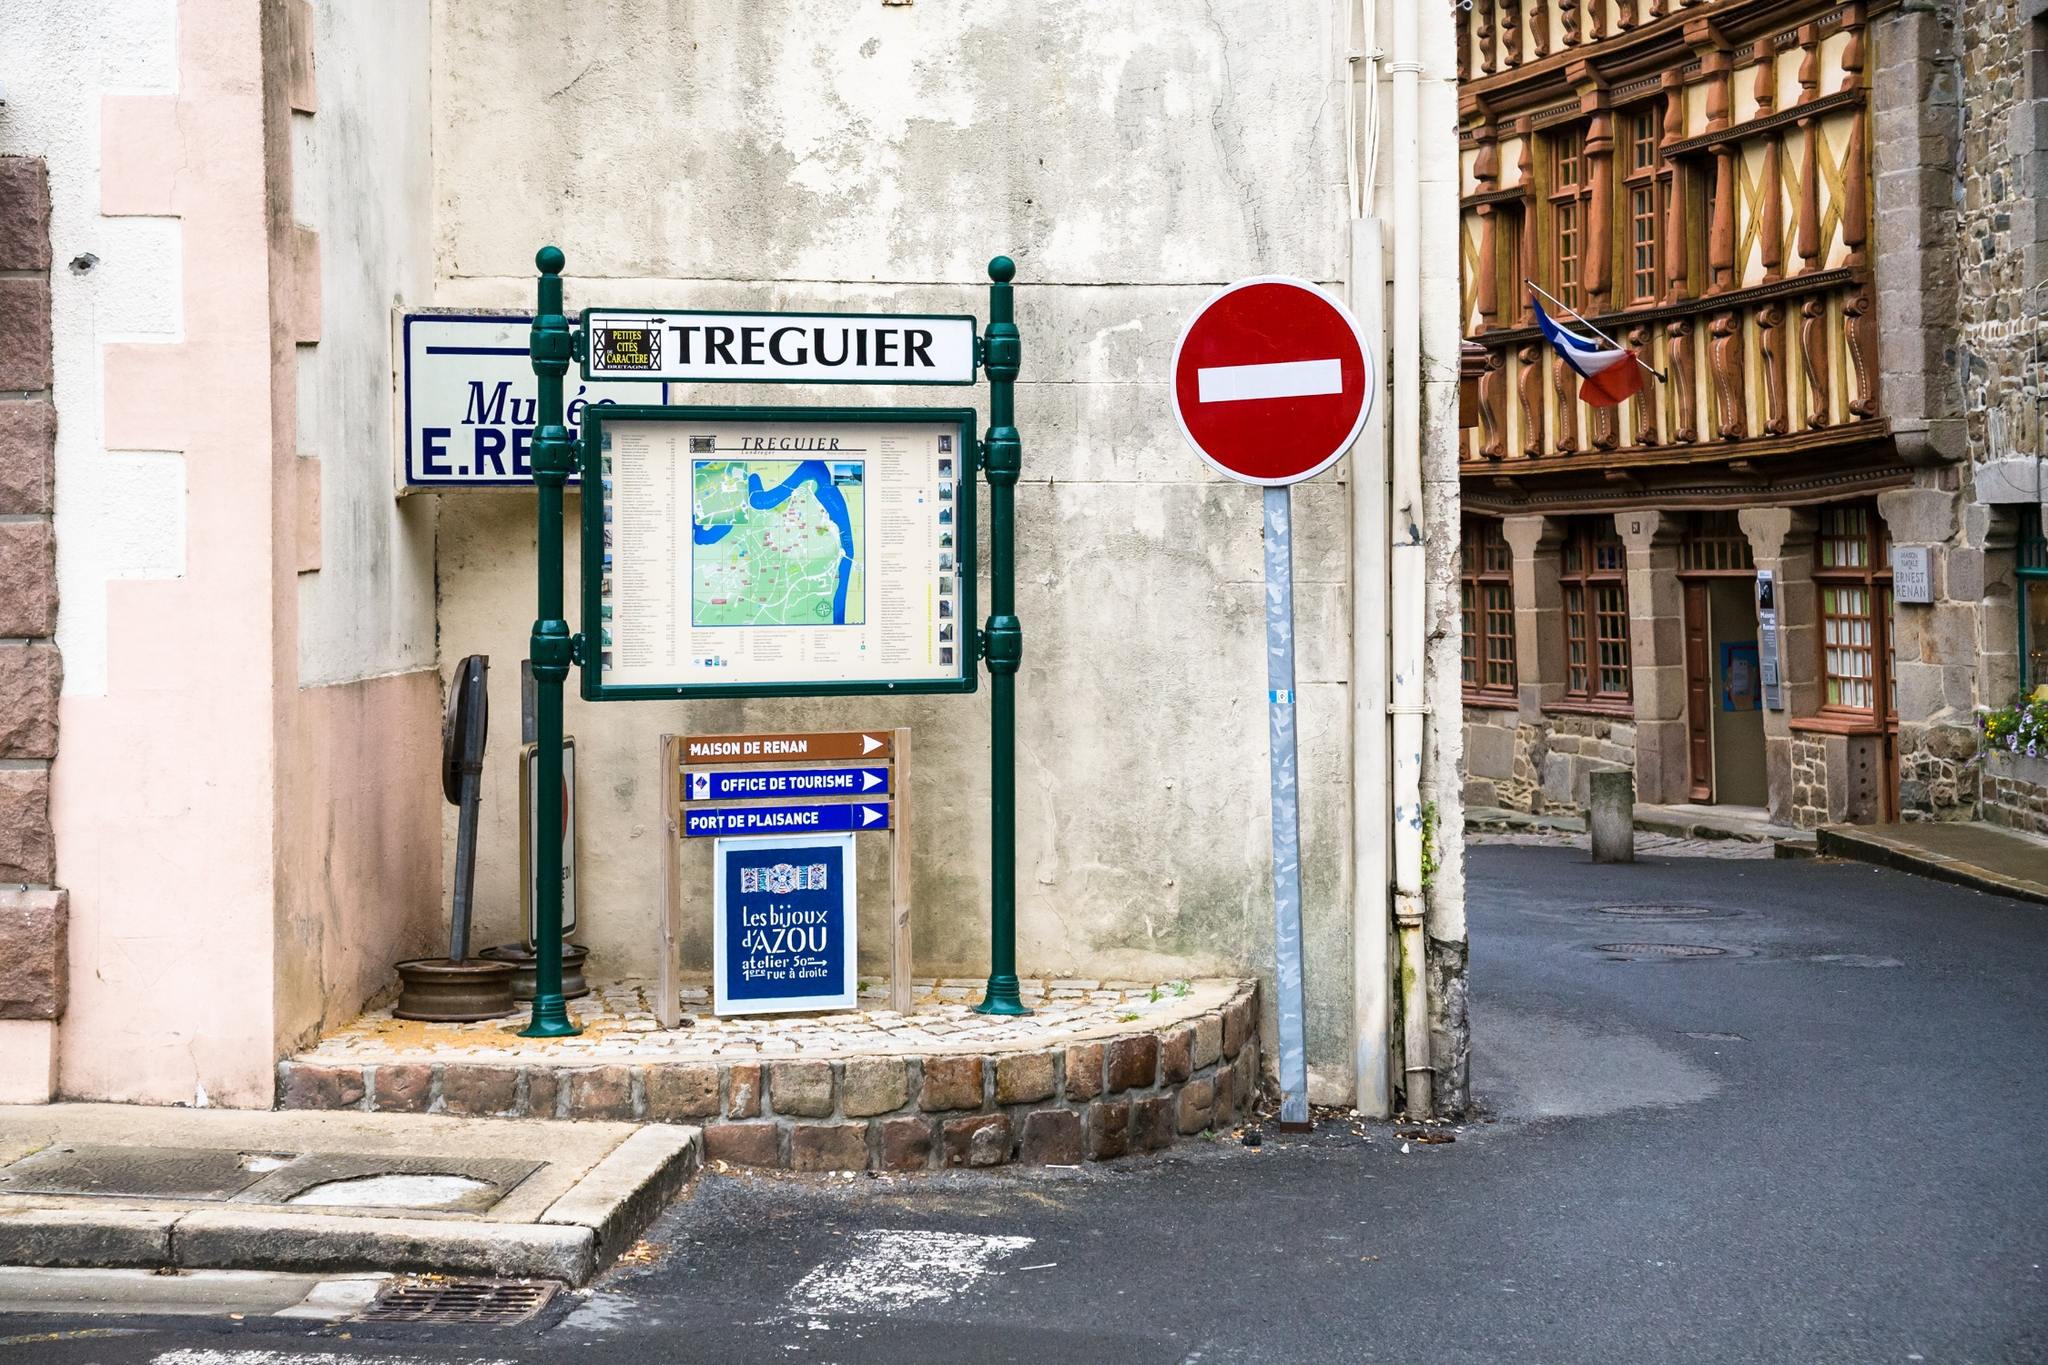What historical details can you provide about the building with the timber facade? The building with the timber facade likely dates back several centuries and is an excellent example of traditional Breton architecture. It proudly displays the French flag, and the sign indicates it houses the 'Musée E.R. Tréguier,' which might contain exhibits on local history, emphasizing figures like Ernest Renan, a notable philosopher from Tréguier. 